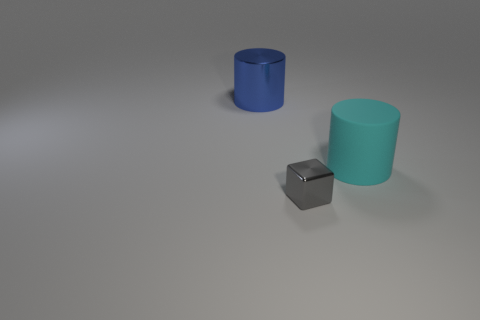There is a cylinder that is behind the big thing that is on the right side of the blue metallic cylinder that is to the left of the gray metallic object; what is it made of?
Make the answer very short. Metal. Is there a matte cylinder that has the same size as the gray block?
Provide a short and direct response. No. What is the shape of the gray metallic thing?
Keep it short and to the point. Cube. What number of cylinders are cyan matte objects or big shiny objects?
Keep it short and to the point. 2. Is the number of tiny things that are to the left of the small metal block the same as the number of matte cylinders behind the big shiny cylinder?
Keep it short and to the point. Yes. How many cyan matte things are on the right side of the cylinder that is to the right of the object on the left side of the tiny gray block?
Provide a succinct answer. 0. Is the color of the matte cylinder the same as the cylinder that is behind the cyan rubber thing?
Your answer should be very brief. No. Are there more large shiny cylinders behind the big cyan rubber cylinder than matte cylinders?
Your answer should be compact. No. What number of objects are cylinders that are on the left side of the gray shiny cube or objects behind the gray object?
Keep it short and to the point. 2. The object that is the same material as the large blue cylinder is what size?
Offer a very short reply. Small. 